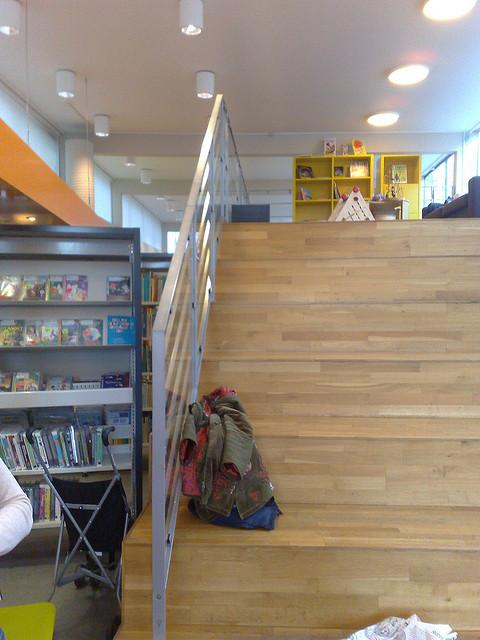What is next to the wooden steps? Please explain your reasoning. railing. There is a silver railing next to the wooden steps for people to hold while going up or down.l 